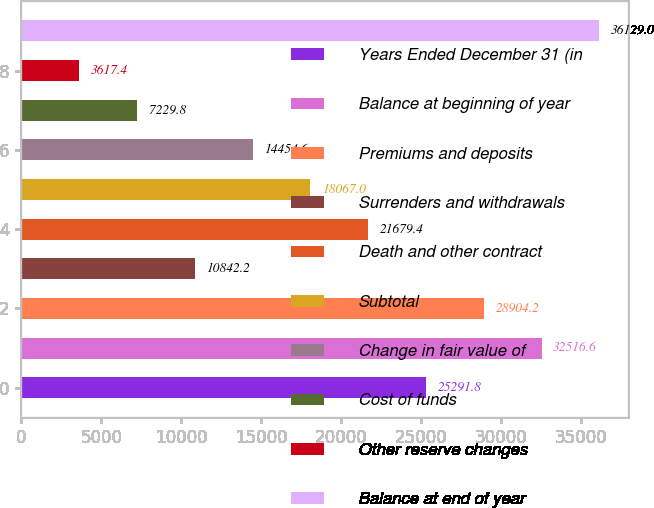<chart> <loc_0><loc_0><loc_500><loc_500><bar_chart><fcel>Years Ended December 31 (in<fcel>Balance at beginning of year<fcel>Premiums and deposits<fcel>Surrenders and withdrawals<fcel>Death and other contract<fcel>Subtotal<fcel>Change in fair value of<fcel>Cost of funds<fcel>Other reserve changes<fcel>Balance at end of year<nl><fcel>25291.8<fcel>32516.6<fcel>28904.2<fcel>10842.2<fcel>21679.4<fcel>18067<fcel>14454.6<fcel>7229.8<fcel>3617.4<fcel>36129<nl></chart> 